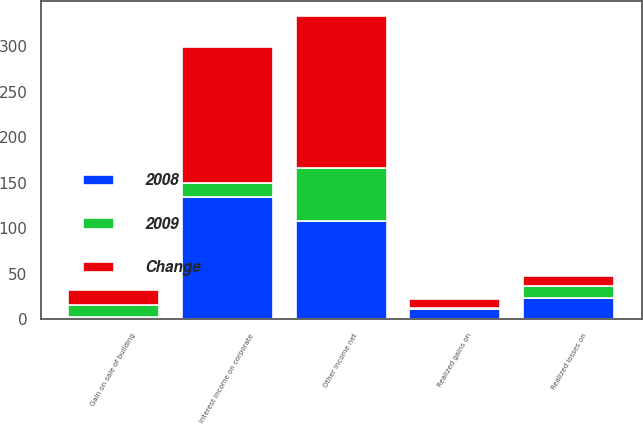Convert chart. <chart><loc_0><loc_0><loc_500><loc_500><stacked_bar_chart><ecel><fcel>Interest income on corporate<fcel>Gain on sale of building<fcel>Realized gains on<fcel>Realized losses on<fcel>Other income net<nl><fcel>2008<fcel>134.2<fcel>2.2<fcel>11.4<fcel>23.8<fcel>108<nl><fcel>Change<fcel>149.5<fcel>16<fcel>10.1<fcel>11.4<fcel>166.5<nl><fcel>2009<fcel>15.3<fcel>13.8<fcel>1.3<fcel>12.4<fcel>58.5<nl></chart> 